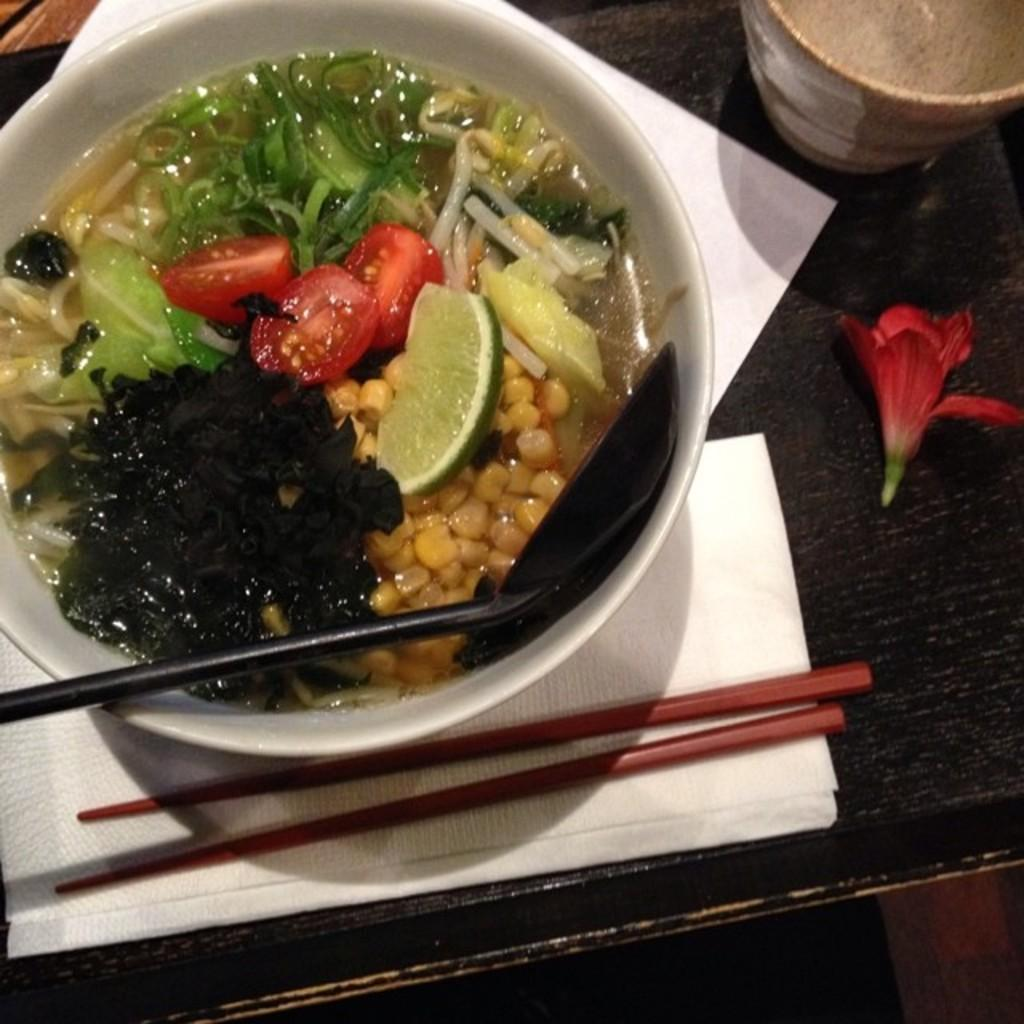What type of furniture is present in the image? There is a table in the image. What is on the table? There is a bowl with food, tissue, chopsticks, a flower, a glass with a drink, and a black cloth on the table. What can be used for eating the food in the bowl? Chopsticks are visible on the table. What decorative item is present on the table? There is a flower on the table. What is the name of the daughter who is not present in the image? There is no daughter mentioned or present in the image. What type of trade is being conducted in the image? There is no trade being conducted in the image; it is a still life of a table setting. 